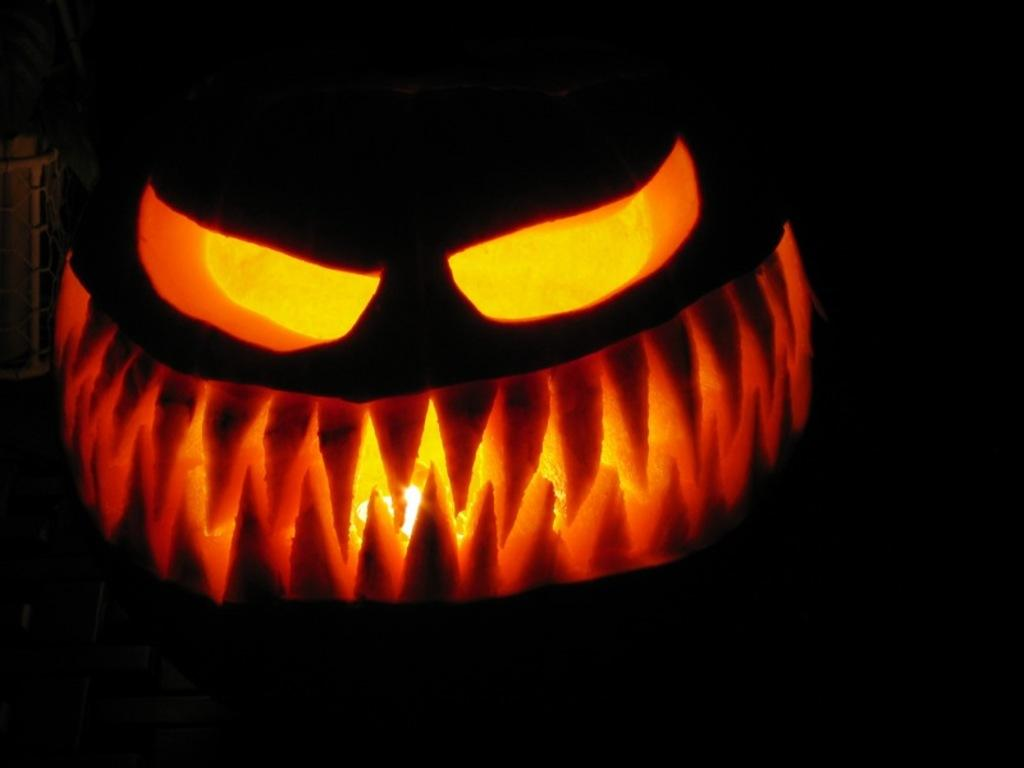What is the main subject of the image? The main subject of the image is an object in the shape of a person's face. What feature does the object have? The object has a light arranged in its shape. What can be observed about the background of the image? The background of the image is dark in color. What type of cup can be seen in the image? There is no cup present in the image; it features an object in the shape of a person's face with a light arranged in its shape. Can you hear the voice of the person in the image? There is no person or voice present in the image; it is an object in the shape of a person's face with a light arranged in its shape. 